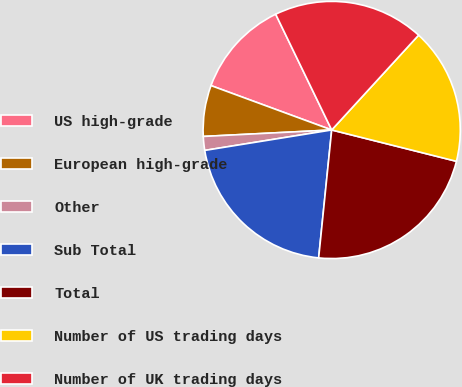Convert chart to OTSL. <chart><loc_0><loc_0><loc_500><loc_500><pie_chart><fcel>US high-grade<fcel>European high-grade<fcel>Other<fcel>Sub Total<fcel>Total<fcel>Number of US trading days<fcel>Number of UK trading days<nl><fcel>12.22%<fcel>6.41%<fcel>1.74%<fcel>20.84%<fcel>22.7%<fcel>17.11%<fcel>18.98%<nl></chart> 